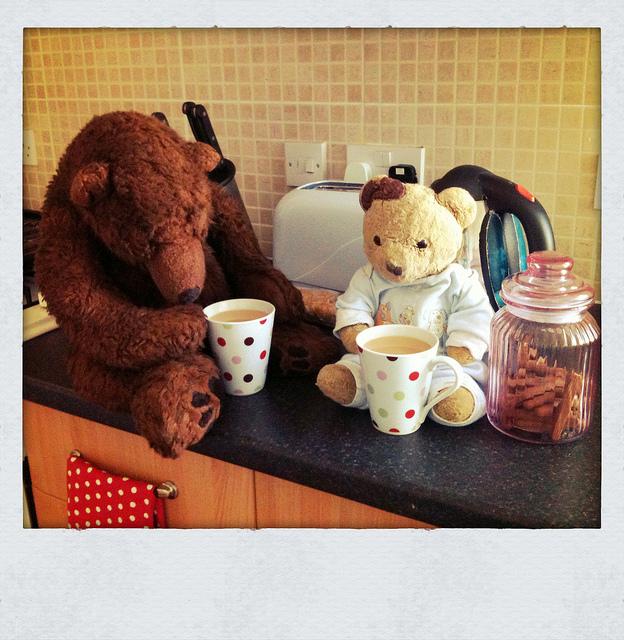What color is the towel hanging below the solid brown bear?
Answer briefly. Red and white. How many bears are there?
Be succinct. 2. What is in the jar?
Give a very brief answer. Cookies. 